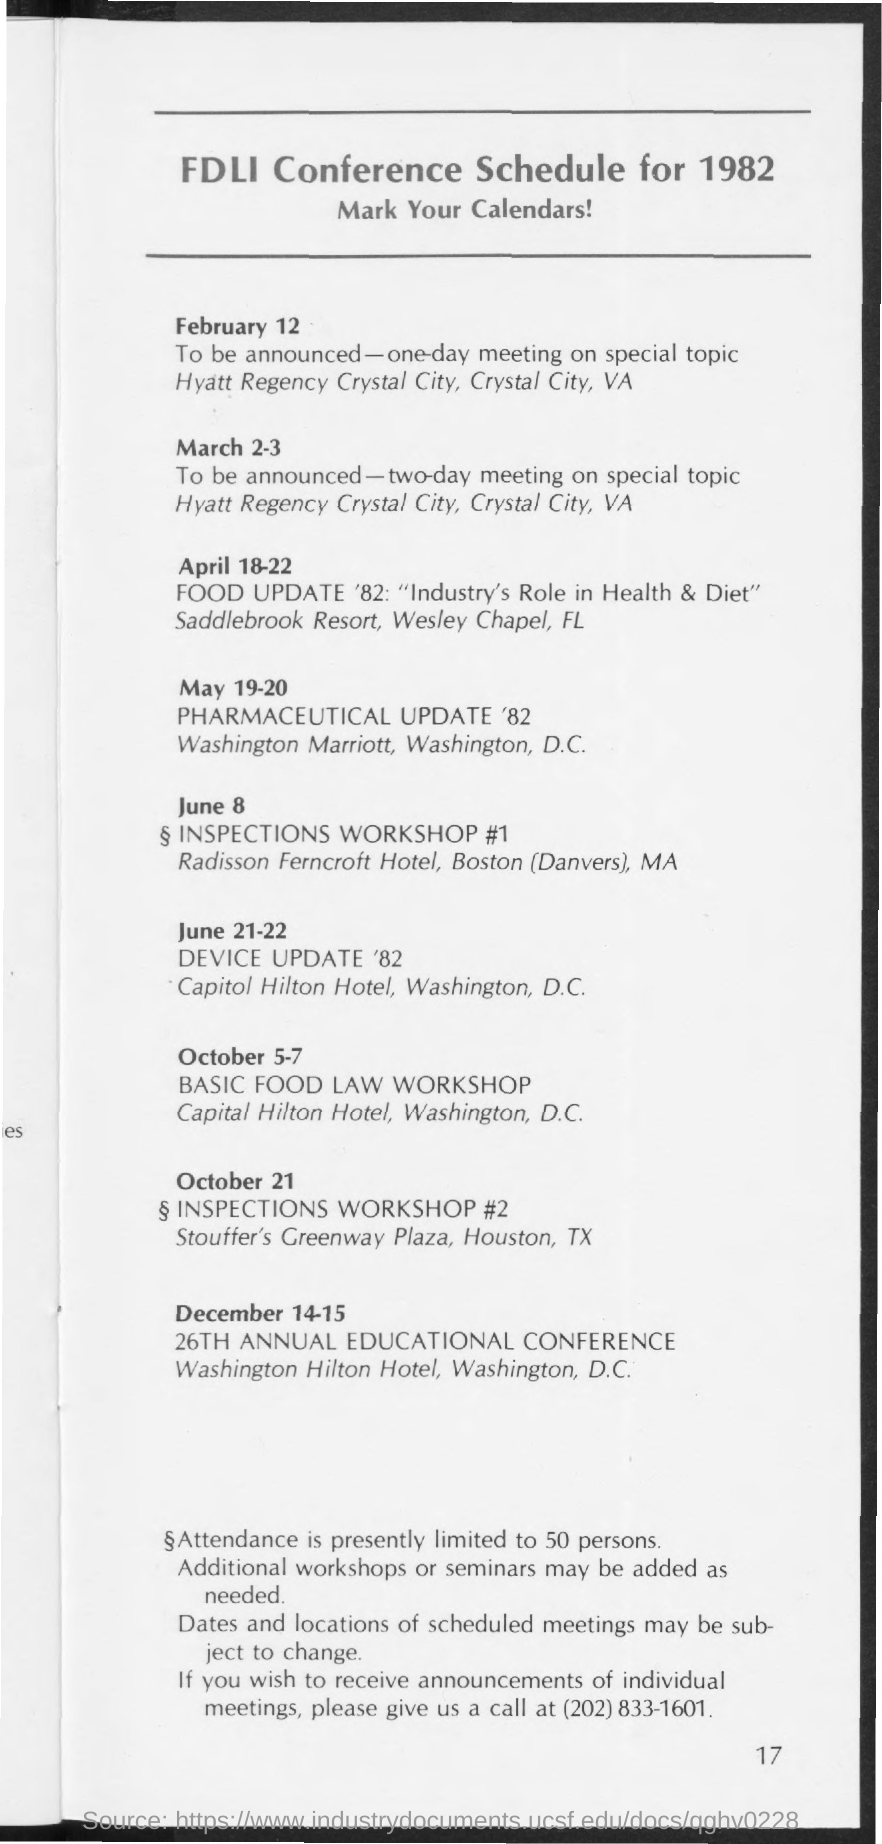What is the page number of this document?
Provide a succinct answer. 17. Where did "26th annual educational conference" held?
Offer a terse response. Washington Hilton Hotel, Washington, D.C. What is the title of document?
Your answer should be compact. FDLI Conference Schedule for 1982. What is the phone number written in the document?
Your response must be concise. (202) 833-1601. 